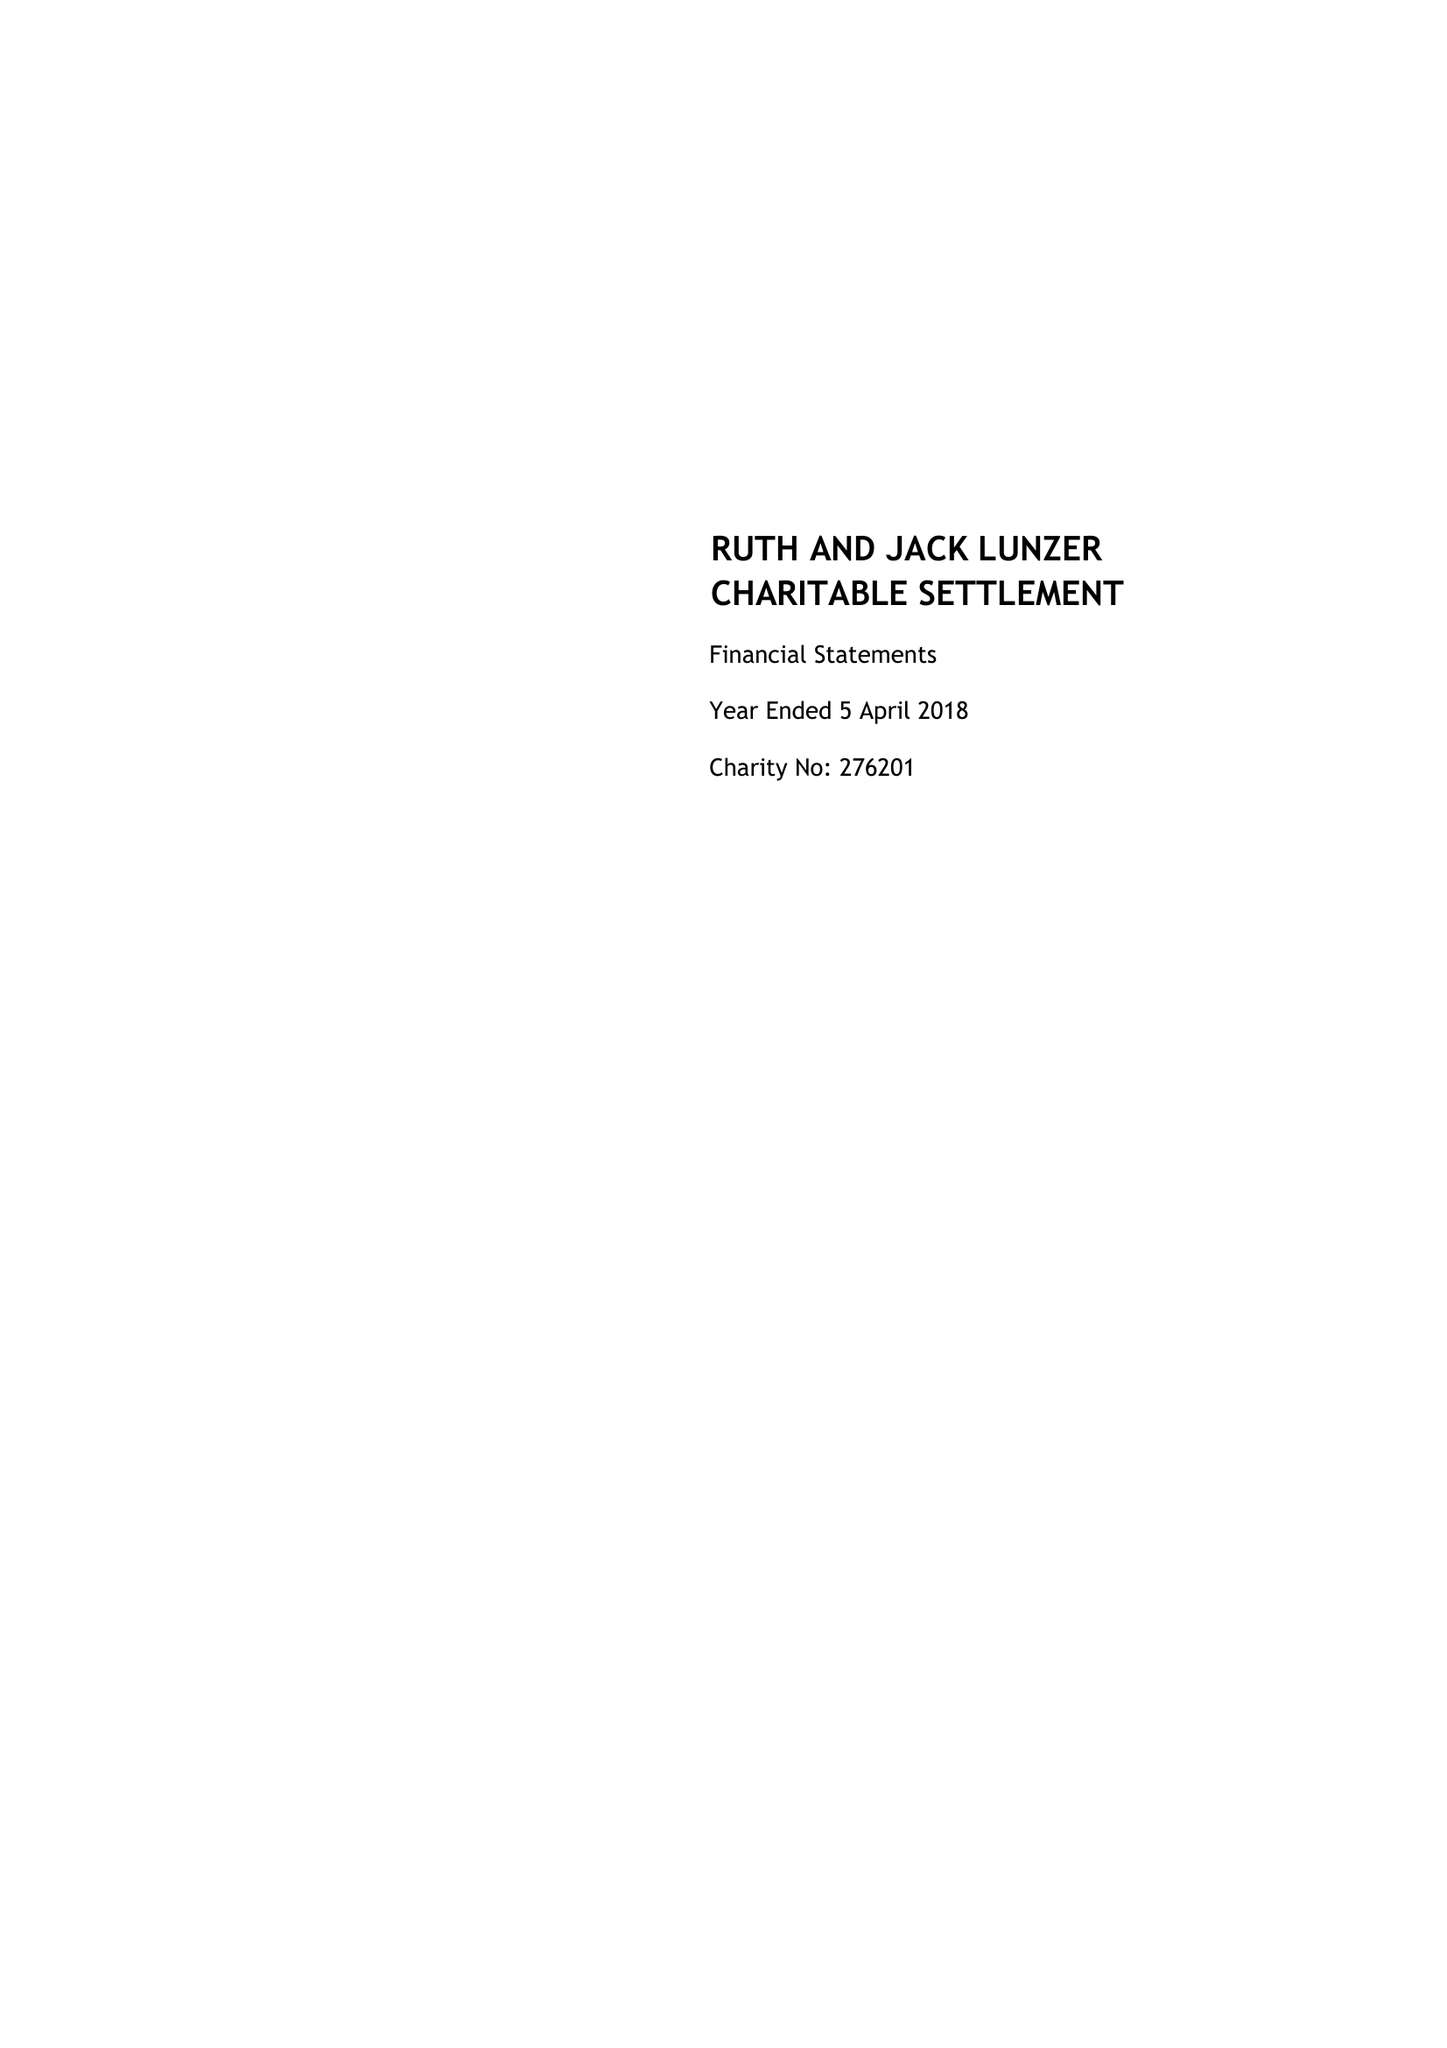What is the value for the charity_number?
Answer the question using a single word or phrase. 276201 